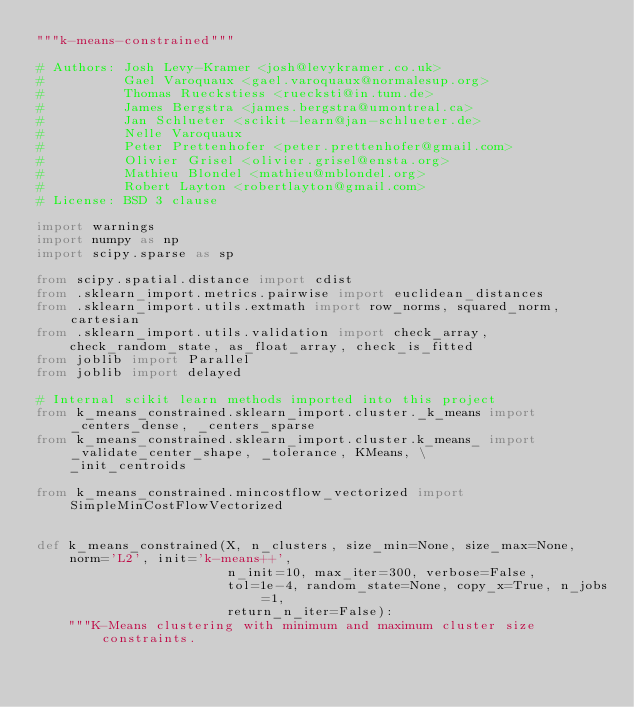<code> <loc_0><loc_0><loc_500><loc_500><_Python_>"""k-means-constrained"""

# Authors: Josh Levy-Kramer <josh@levykramer.co.uk>
#          Gael Varoquaux <gael.varoquaux@normalesup.org>
#          Thomas Rueckstiess <ruecksti@in.tum.de>
#          James Bergstra <james.bergstra@umontreal.ca>
#          Jan Schlueter <scikit-learn@jan-schlueter.de>
#          Nelle Varoquaux
#          Peter Prettenhofer <peter.prettenhofer@gmail.com>
#          Olivier Grisel <olivier.grisel@ensta.org>
#          Mathieu Blondel <mathieu@mblondel.org>
#          Robert Layton <robertlayton@gmail.com>
# License: BSD 3 clause

import warnings
import numpy as np
import scipy.sparse as sp

from scipy.spatial.distance import cdist
from .sklearn_import.metrics.pairwise import euclidean_distances
from .sklearn_import.utils.extmath import row_norms, squared_norm, cartesian
from .sklearn_import.utils.validation import check_array, check_random_state, as_float_array, check_is_fitted
from joblib import Parallel
from joblib import delayed

# Internal scikit learn methods imported into this project
from k_means_constrained.sklearn_import.cluster._k_means import _centers_dense, _centers_sparse
from k_means_constrained.sklearn_import.cluster.k_means_ import _validate_center_shape, _tolerance, KMeans, \
    _init_centroids

from k_means_constrained.mincostflow_vectorized import SimpleMinCostFlowVectorized


def k_means_constrained(X, n_clusters, size_min=None, size_max=None, norm='L2', init='k-means++',
                        n_init=10, max_iter=300, verbose=False,
                        tol=1e-4, random_state=None, copy_x=True, n_jobs=1,
                        return_n_iter=False):
    """K-Means clustering with minimum and maximum cluster size constraints.
</code> 